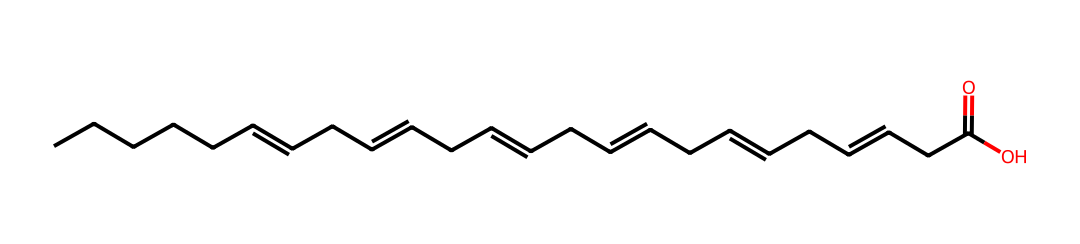How many carbon atoms are in this molecule? The SMILES representation indicates the presence of a long carbon chain. By counting the number of 'C's in the SMILES notation, we find that there are 18 carbon atoms.
Answer: 18 What is the functional group present in this compound? The structure ends with 'C(=O)O', which denotes a carboxylic acid group. This group consists of a carbonyl (C=O) and a hydroxyl (-OH) group, characteristic of fatty acids.
Answer: carboxylic acid What type of lipid is represented by this structure? The presence of multiple double bonds in the carbon chain indicates that it is an unsaturated fatty acid, specifically a polyunsaturated fatty acid because it has more than one double bond.
Answer: polyunsaturated fatty acid How many double bonds are present in this fatty acid? By examining the double bonds shown in the structure, there are a total of 5 double bonds, which can be identified by the '=' signs in the chain.
Answer: 5 What is the degree of unsaturation of this fatty acid? The degree of unsaturation can be calculated based on the number of double bonds. Each double bond contributes to one degree of unsaturation, so with 5 double bonds, this fatty acid has a degree of unsaturation of 5.
Answer: 5 Is this fatty acid essential for human health? Omega-3 fatty acids, represented by this structure, are considered essential fatty acids because the human body cannot synthesize them and they must be obtained from the diet.
Answer: yes 